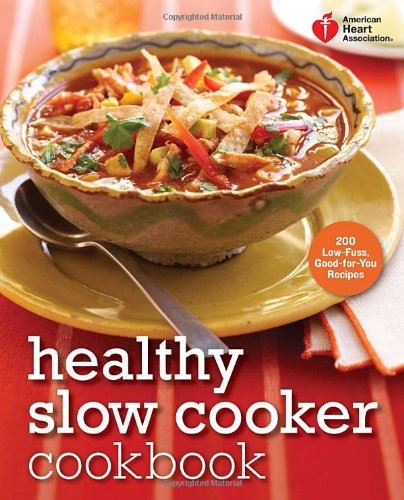What is the genre of this book? This book falls within the 'Cookbooks, Food & Wine' genre. It specifically focuses on healthy recipes that can be made in a slow cooker, designed by the American Heart Association to aid individuals in maintaining a heart-healthy diet. 